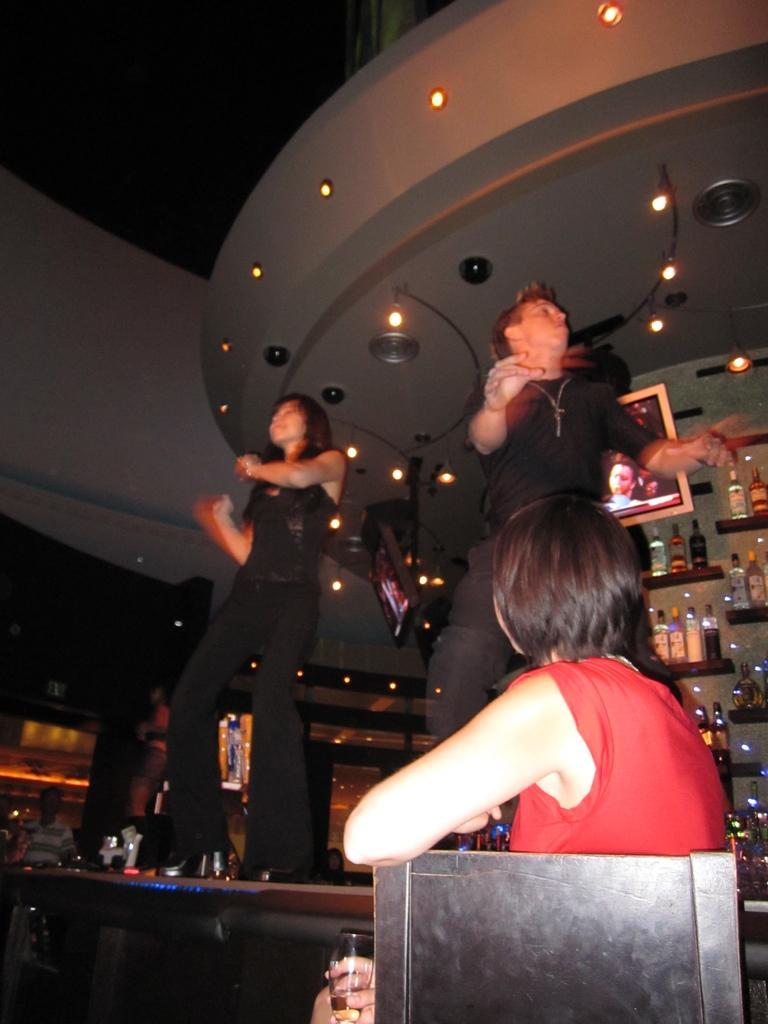Describe this image in one or two sentences. In this image I can see two people standing and wearing black dress. One person is sitting on the chair and holding a glass. I can see a screen and lights. 